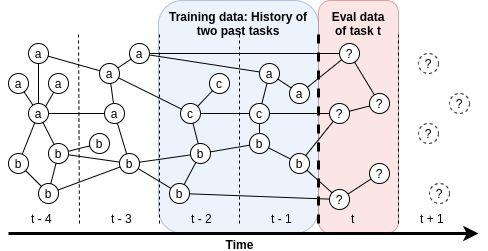What can be inferred about the component 'c' in the context of task performance evaluation? A. 'c' is not considered during the evaluation of tasks. B. 'c' appears to be introduced in the task evaluation at t-2 and remains consistent thereafter. C. 'c' is only used in the training phase and not in the evaluation. D. 'c' has been phased out of the evaluation process over time. In the figure, 'c' first appears in the shaded evaluation area at time t-2 and continues to be present in all subsequent evaluations, indicating that it was introduced at t-2 and remains a consistent part of the evaluation process. Therefore, the correct answer is B. 